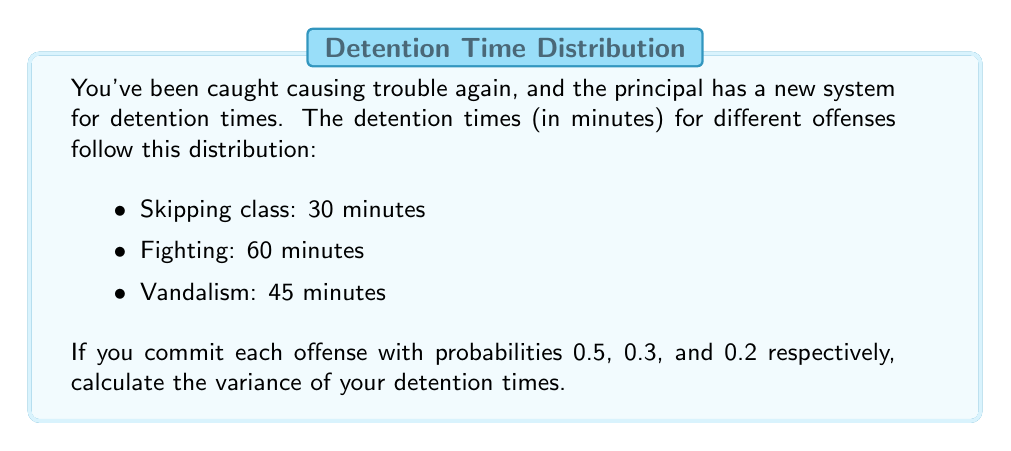Give your solution to this math problem. Let's approach this step-by-step:

1) First, we need to calculate the expected value (mean) of the detention times.

   $E(X) = \sum_{i=1}^{n} x_i \cdot p_i$

   $E(X) = 30 \cdot 0.5 + 60 \cdot 0.3 + 45 \cdot 0.2$
   $E(X) = 15 + 18 + 9 = 42$ minutes

2) Now, we need to calculate $E(X^2)$:

   $E(X^2) = \sum_{i=1}^{n} x_i^2 \cdot p_i$

   $E(X^2) = 30^2 \cdot 0.5 + 60^2 \cdot 0.3 + 45^2 \cdot 0.2$
   $E(X^2) = 450 + 1080 + 405 = 1935$

3) The variance is given by the formula:

   $Var(X) = E(X^2) - [E(X)]^2$

4) Substituting the values:

   $Var(X) = 1935 - 42^2$
   $Var(X) = 1935 - 1764 = 171$

Therefore, the variance of the detention times is 171 square minutes.
Answer: 171 square minutes 